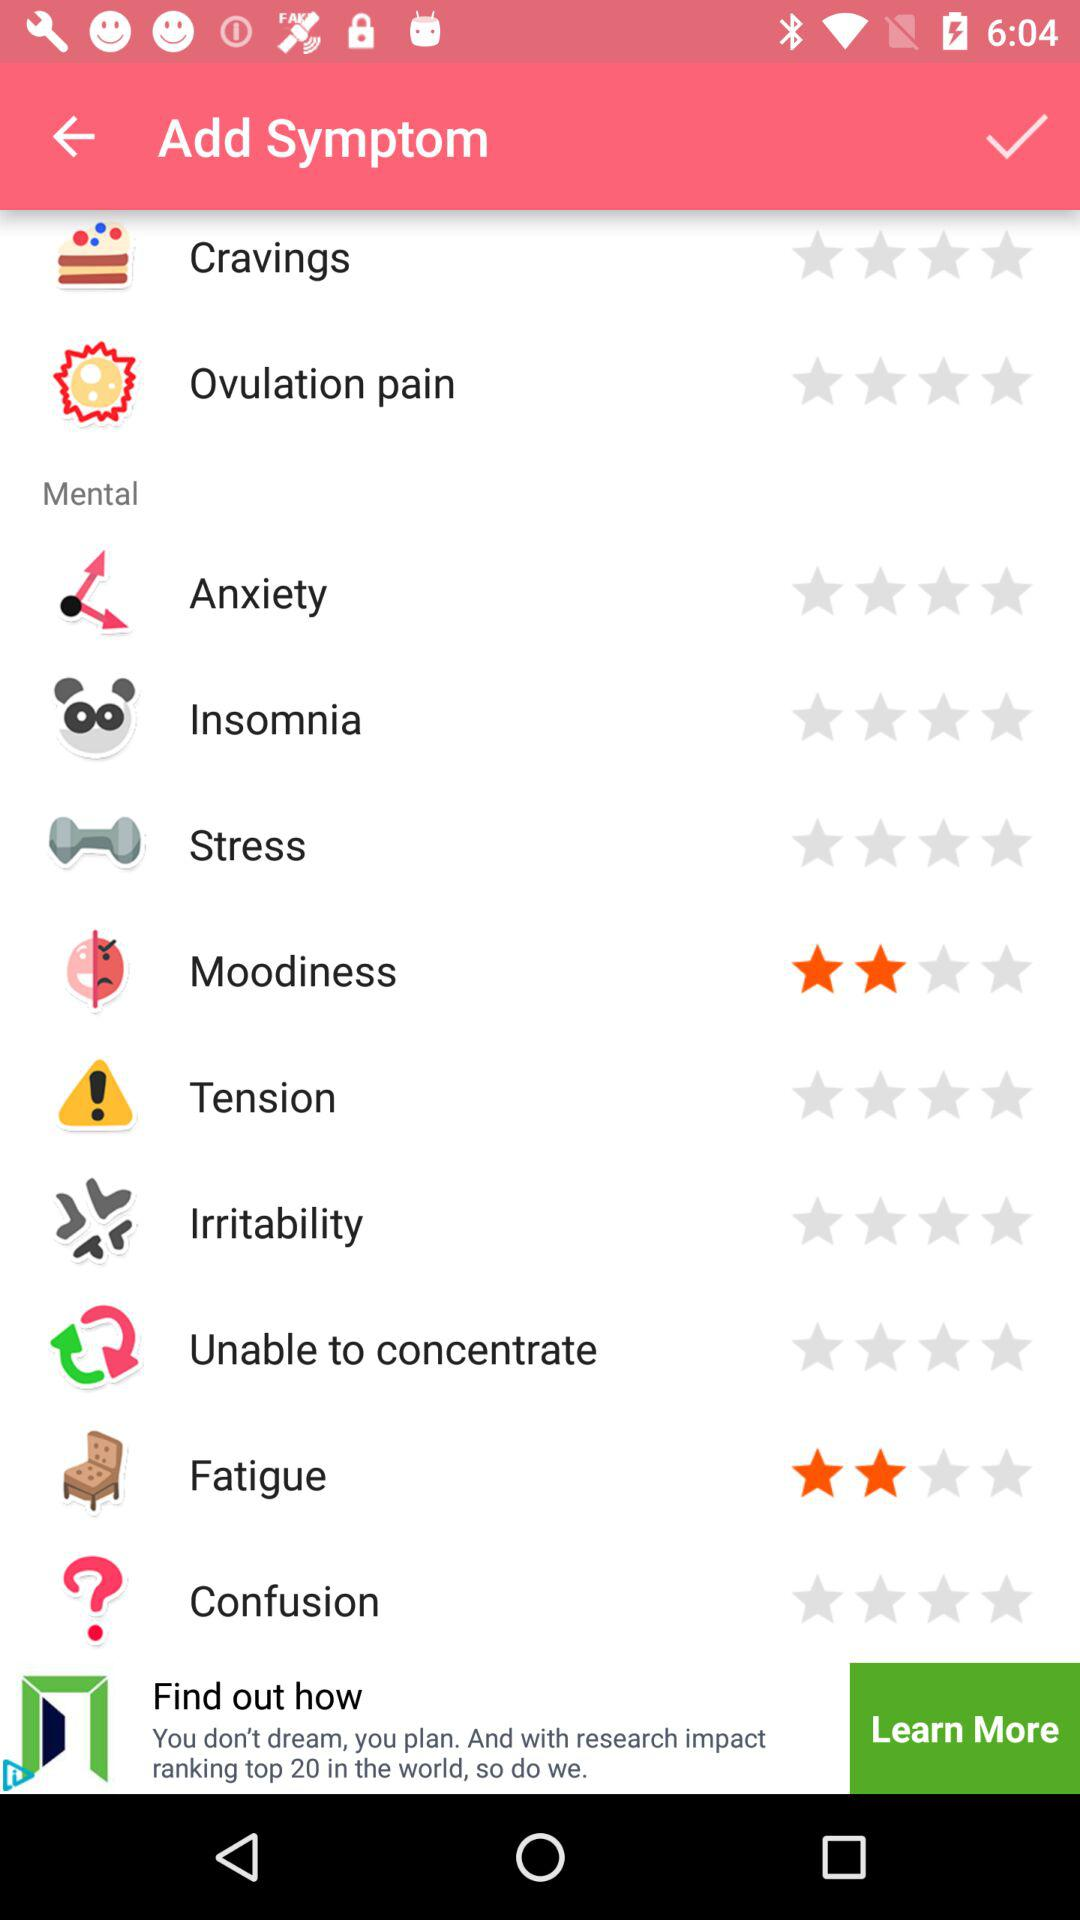Which option has received a rating? The options that have received a rating are "Moodiness" and "Fatigue". 